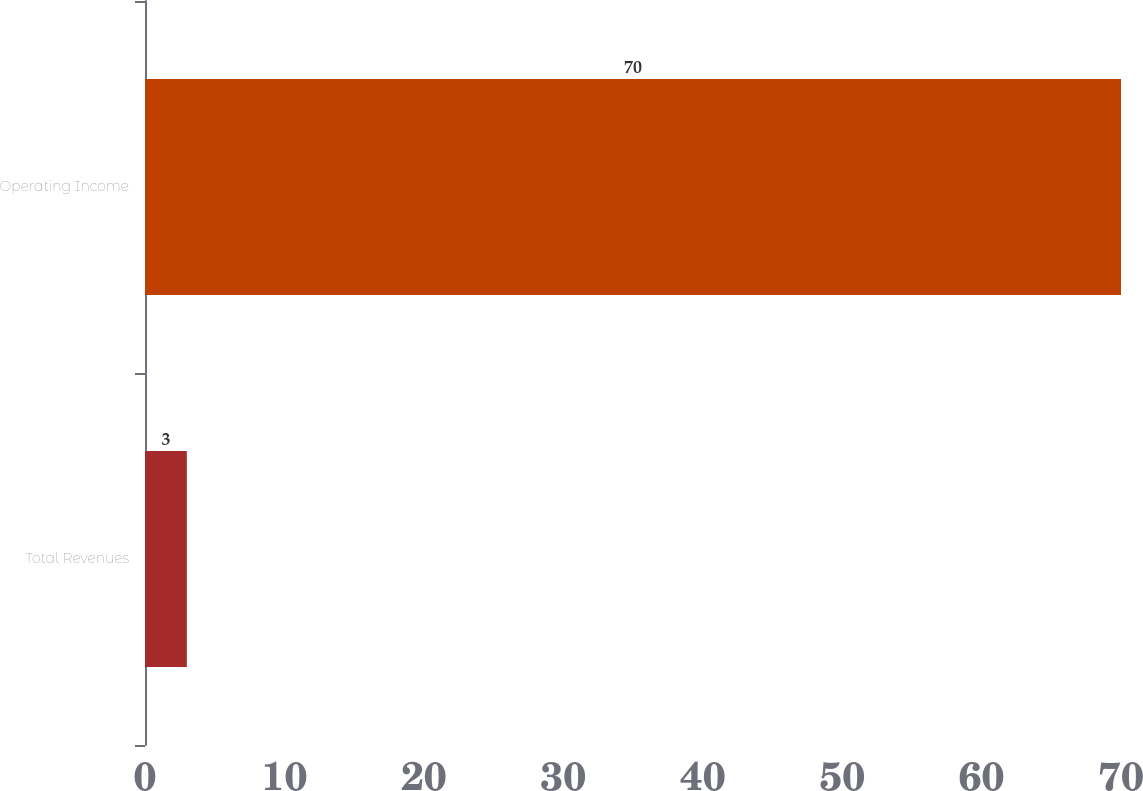<chart> <loc_0><loc_0><loc_500><loc_500><bar_chart><fcel>Total Revenues<fcel>Operating Income<nl><fcel>3<fcel>70<nl></chart> 